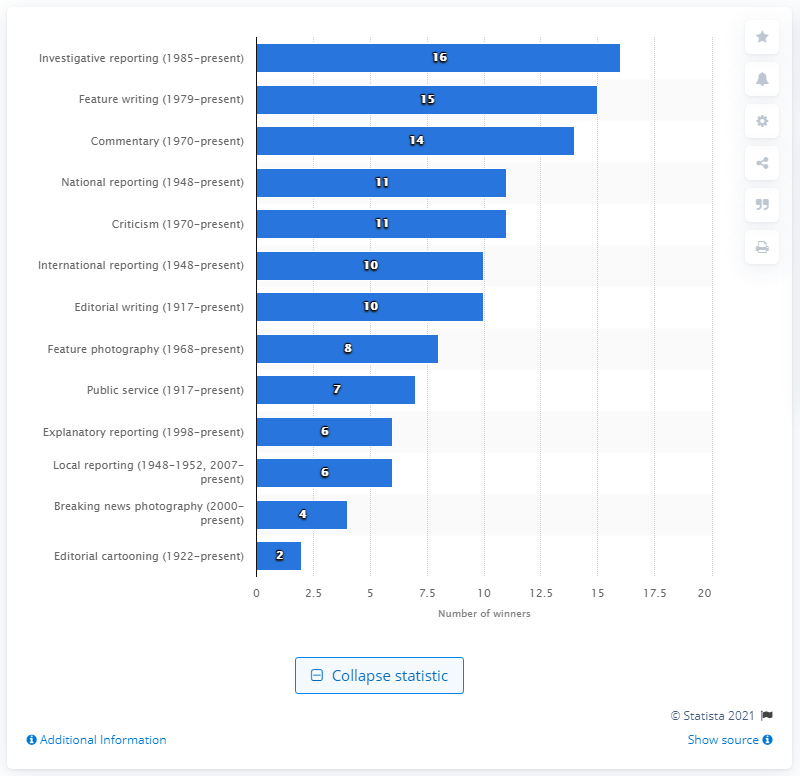Highlight a few significant elements in this photo. Since 1948, 11 women have won the Pulitzer Prize for National Reporting. 